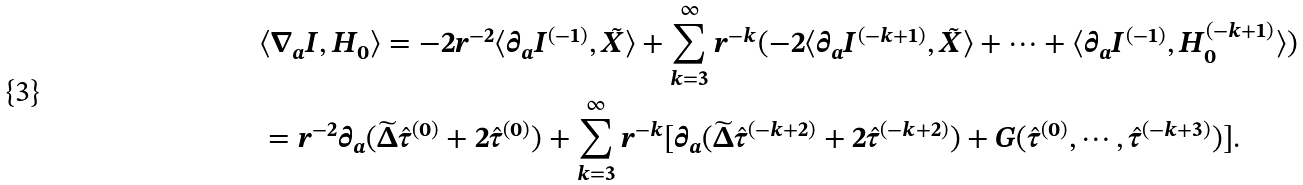<formula> <loc_0><loc_0><loc_500><loc_500>& \langle \nabla _ { a } I , H _ { 0 } \rangle = - 2 r ^ { - 2 } \langle \partial _ { a } I ^ { ( - 1 ) } , \tilde { X } \rangle + \sum _ { k = 3 } ^ { \infty } r ^ { - k } ( - 2 \langle \partial _ { a } I ^ { ( - k + 1 ) } , \tilde { X } \rangle + \cdots + \langle \partial _ { a } I ^ { ( - 1 ) } , H _ { 0 } ^ { ( - k + 1 ) } \rangle ) \\ & = r ^ { - 2 } \partial _ { a } ( \widetilde { \Delta } \hat { \tau } ^ { ( 0 ) } + 2 \hat { \tau } ^ { ( 0 ) } ) + \sum _ { k = 3 } ^ { \infty } r ^ { - k } [ \partial _ { a } ( \widetilde { \Delta } \hat { \tau } ^ { ( - k + 2 ) } + 2 \hat { \tau } ^ { ( - k + 2 ) } ) + G ( \hat { \tau } ^ { ( 0 ) } , \cdots , \hat { \tau } ^ { ( - k + 3 ) } ) ] .</formula> 